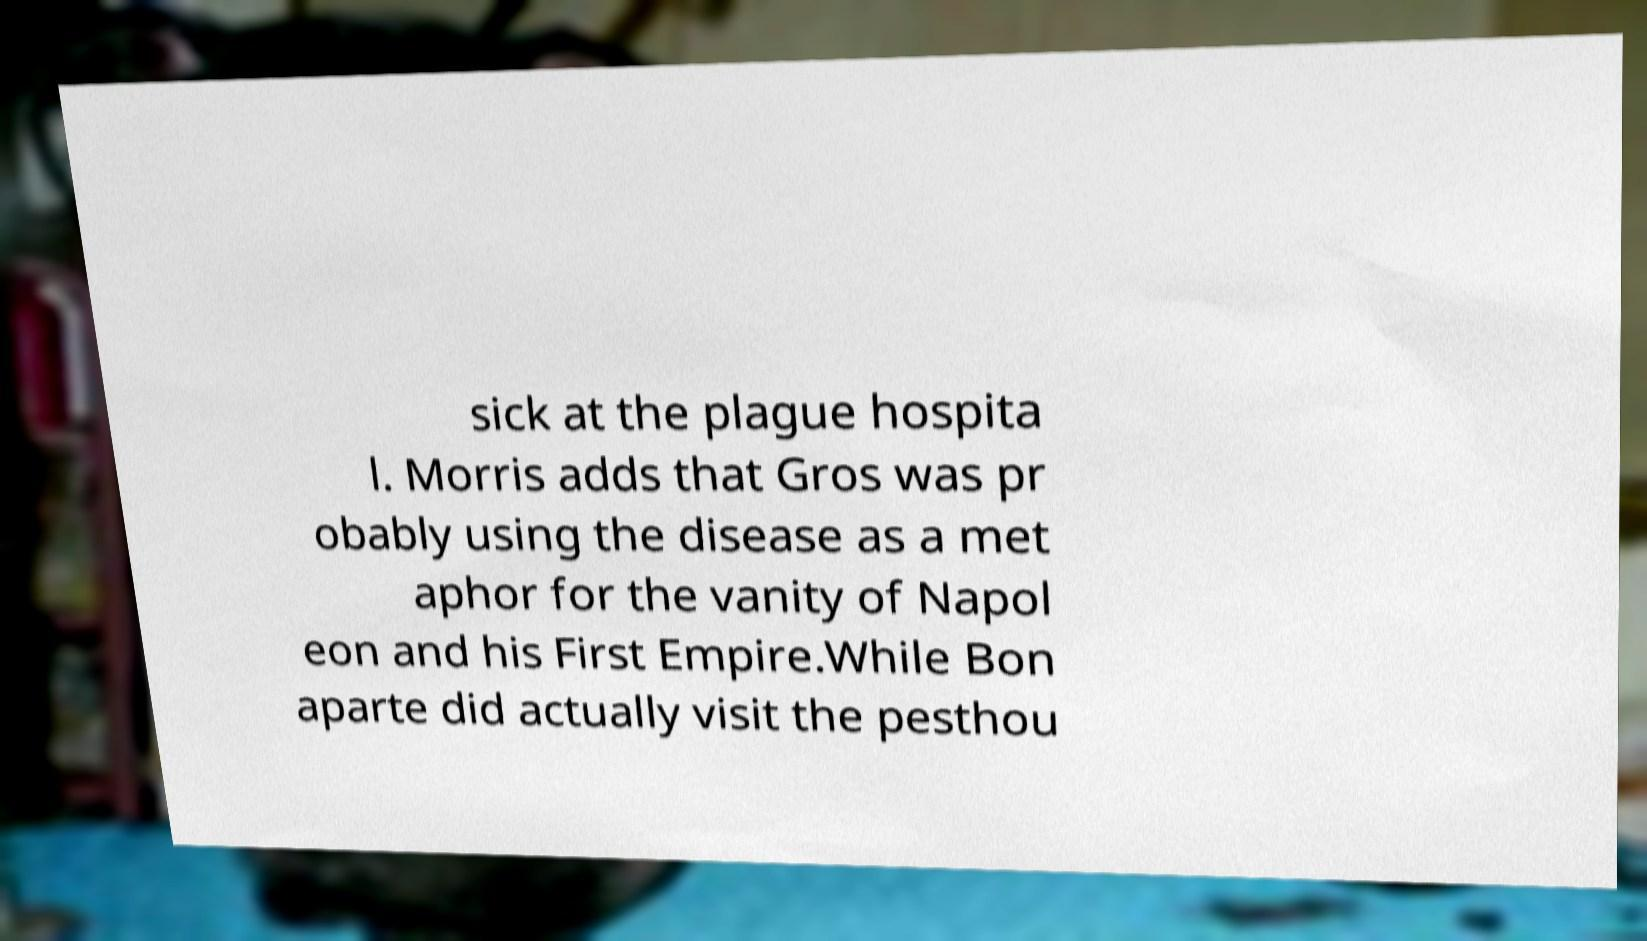What messages or text are displayed in this image? I need them in a readable, typed format. sick at the plague hospita l. Morris adds that Gros was pr obably using the disease as a met aphor for the vanity of Napol eon and his First Empire.While Bon aparte did actually visit the pesthou 